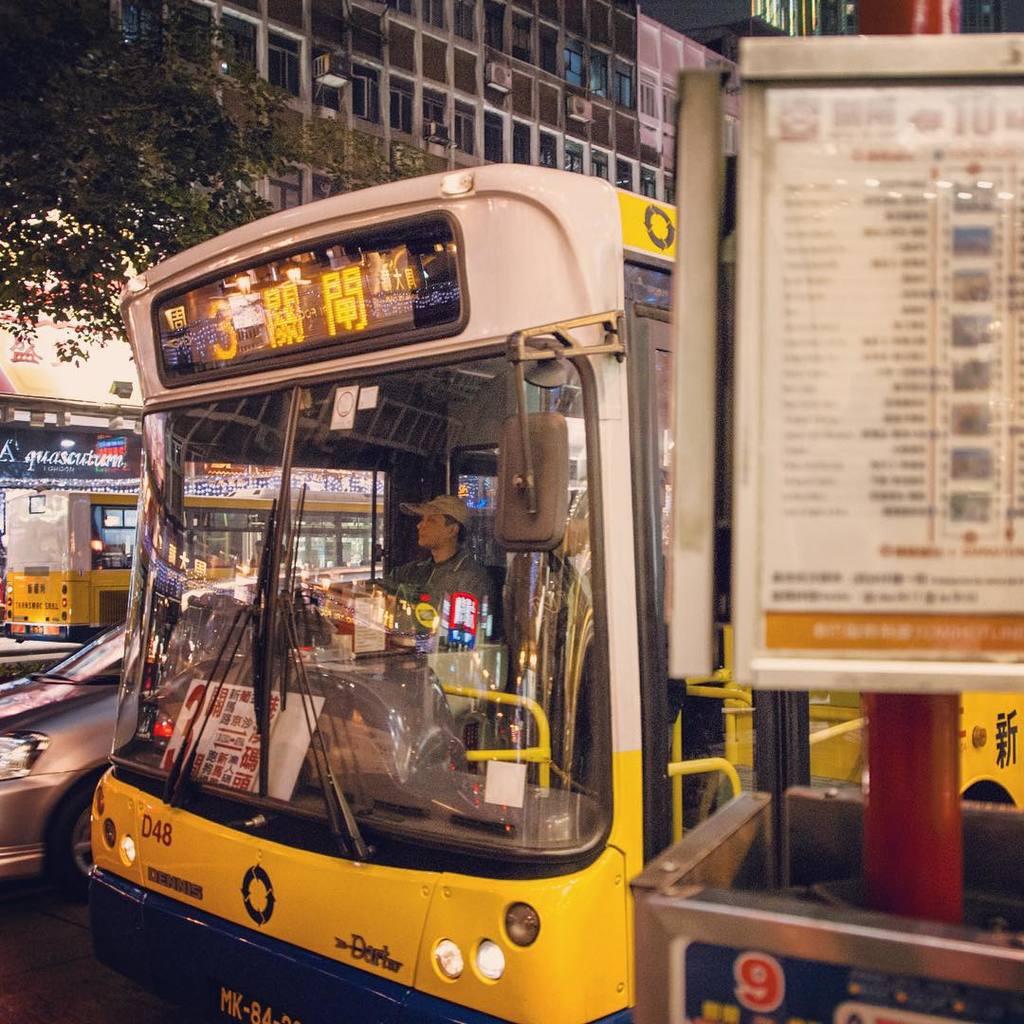What is the route number?
Give a very brief answer. 3. What are the first 2 letters of the license plate?
Your answer should be very brief. Mk. 